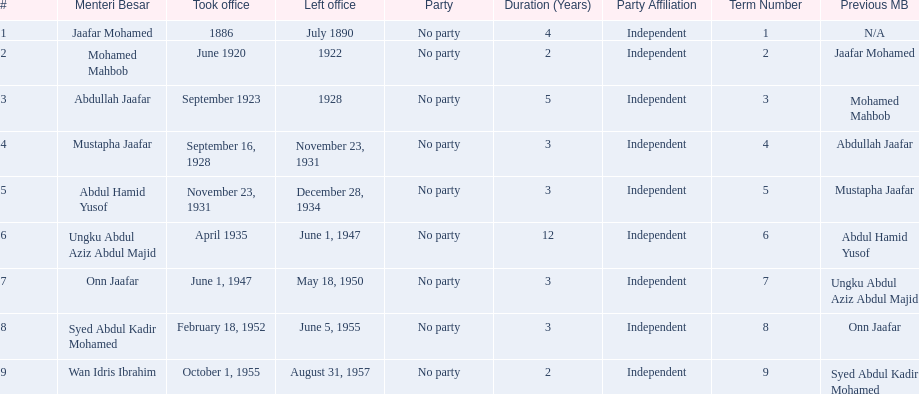What are all the people that were menteri besar of johor? Jaafar Mohamed, Mohamed Mahbob, Abdullah Jaafar, Mustapha Jaafar, Abdul Hamid Yusof, Ungku Abdul Aziz Abdul Majid, Onn Jaafar, Syed Abdul Kadir Mohamed, Wan Idris Ibrahim. Who ruled the longest? Ungku Abdul Aziz Abdul Majid. 